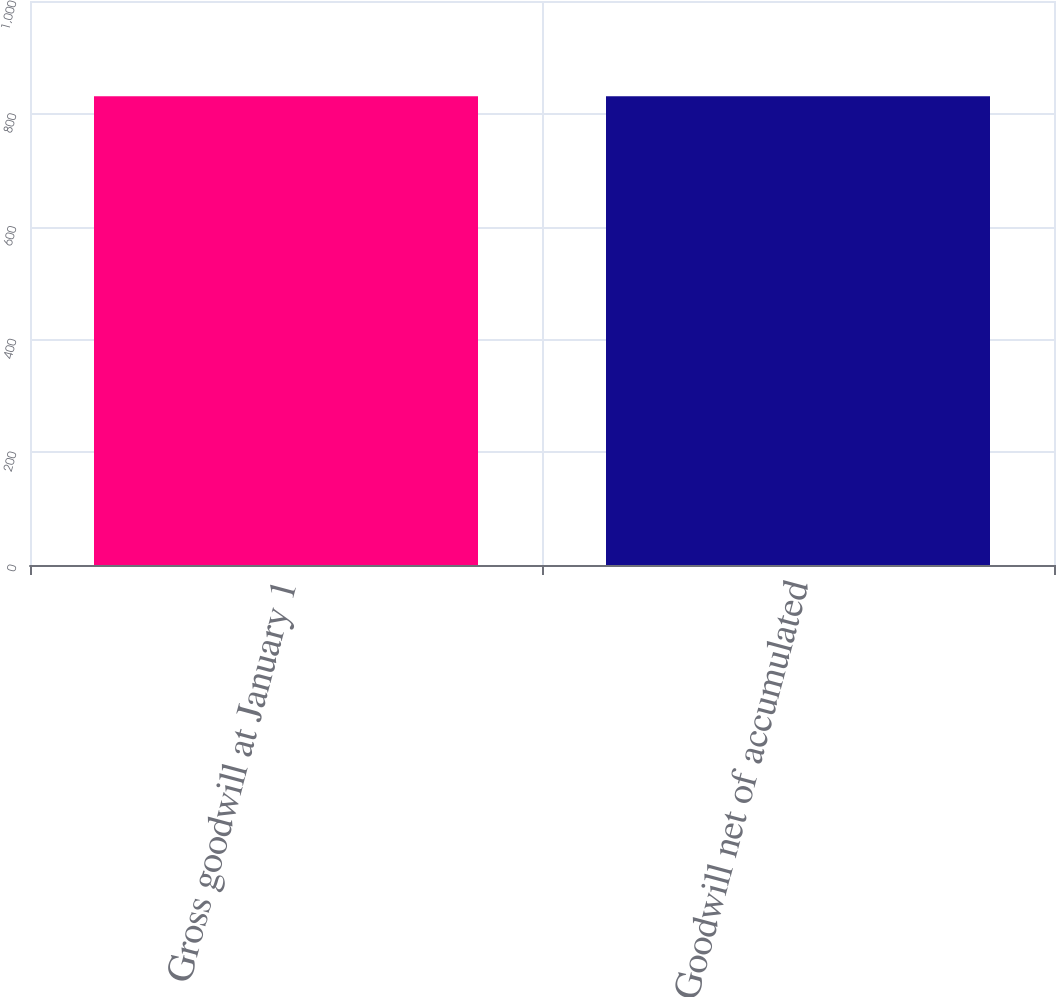Convert chart to OTSL. <chart><loc_0><loc_0><loc_500><loc_500><bar_chart><fcel>Gross goodwill at January 1<fcel>Goodwill net of accumulated<nl><fcel>831<fcel>831.1<nl></chart> 